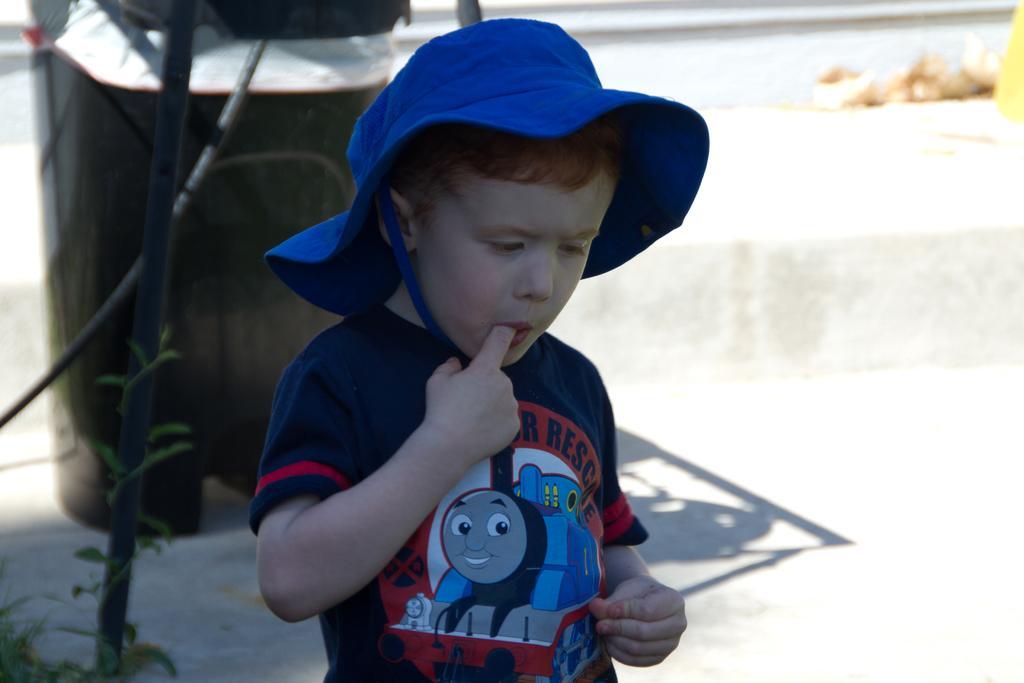In one or two sentences, can you explain what this image depicts? In this image there is a boy wearing hat, in the background there is a rod and a dustbin and plant, in the background it is blurred. 